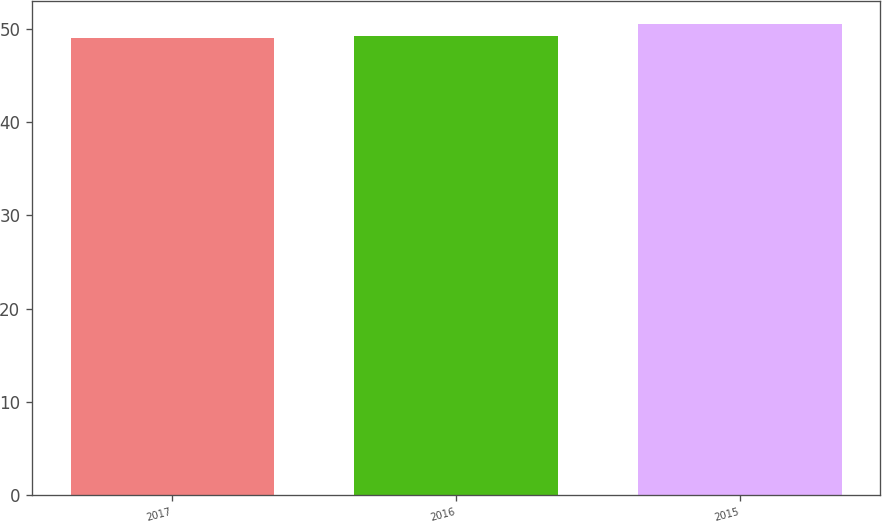Convert chart to OTSL. <chart><loc_0><loc_0><loc_500><loc_500><bar_chart><fcel>2017<fcel>2016<fcel>2015<nl><fcel>49.1<fcel>49.3<fcel>50.5<nl></chart> 